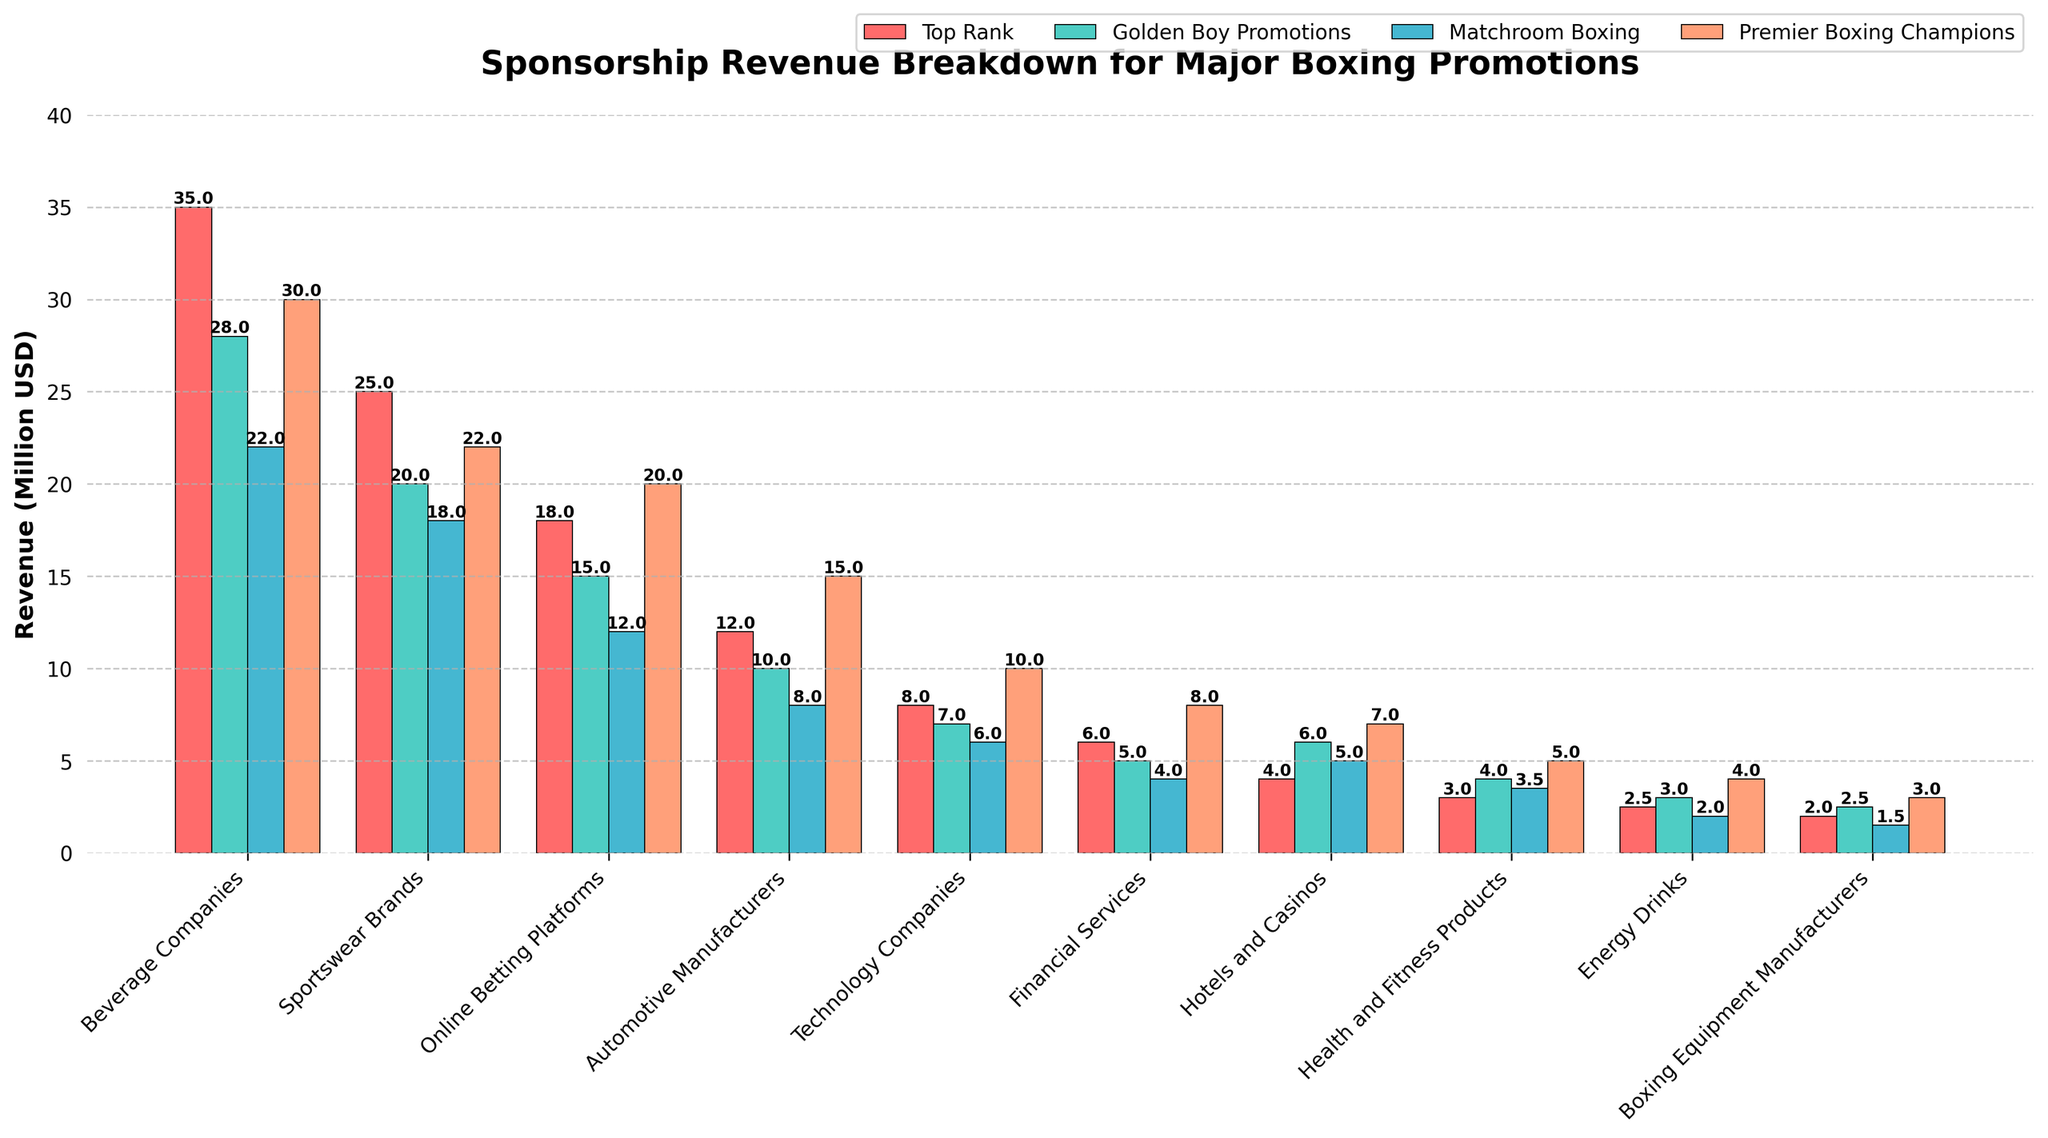What's the total sponsorship revenue for Top Rank across all industry sectors? To find this, sum up all the revenues for Top Rank: 35 + 25 + 18 + 12 + 8 + 6 + 4 + 3 + 2.5 + 2 = 115.5 million USD
Answer: 115.5 million USD Which industry sector brings the highest sponsorship revenue for Golden Boy Promotions? By examining the bars corresponding to Golden Boy Promotions, the Beverage Companies sector has the highest sponsorship revenue at 28 million USD
Answer: Beverage Companies Among all the promotions, which has the least revenue from the Automotive Manufacturers sector? Top Rank: 12 million, Golden Boy Promotions: 10 million, Matchroom Boxing: 8 million, Premier Boxing Champions: 15 million. Matchroom Boxing has the least at 8 million USD
Answer: Matchroom Boxing How much more revenue does Top Rank get from Beverage Companies compared to Technology Companies? Top Rank's revenue from Beverage Companies is 35 million, and from Technology Companies is 8 million. The difference is 35 - 8 = 27 million USD
Answer: 27 million USD Which promotion has the highest average revenue across all industry sectors? Calculate the average for each promotion: Top Rank: (35+25+18+12+8+6+4+3+2.5+2)/10 = 11.55 million USD, Golden Boy Promotions: (28+20+15+10+7+5+6+4+3+2.5)/10 = 10.15 million USD, Matchroom Boxing: (22+18+12+8+6+4+5+3.5+2+1.5)/10 = 8.95 million USD, Premier Boxing Champions: (30+22+20+15+10+8+7+5+4+3)/10 = 12.4 million USD. Premier Boxing Champions has the highest average at 12.4 million USD
Answer: Premier Boxing Champions Which promotion has the smallest revenue difference between the top two sectors? Calculate the difference for each promotion: Top Rank: 35-25=10, Golden Boy Promotions: 28-20=8, Matchroom Boxing: 22-18=4, Premier Boxing Champions: 30-22=8. Matchroom Boxing has the smallest difference at 4 million USD
Answer: Matchroom Boxing How much revenue does Premier Boxing Champions get from the three least contributing sectors? Identify the least contributing sectors: Technology Companies (10), Financial Services (8), Boxing Equipment Manufacturers (3). Summing these revenues: 10 + 8 + 3 = 21 million USD
Answer: 21 million USD Compare the revenue from Energy Drinks between Premier Boxing Champions and Matchroom Boxing. Which one earns more and by how much? Premier Boxing Champions has 4 million USD, while Matchroom Boxing has 2 million USD. The difference is 4 - 2 = 2 million USD
Answer: Premier Boxing Champions, 2 million USD What is the combined contribution of Online Betting Platforms to all promotions? Sum up the contributions from each promotion: 18 + 15 + 12 + 20 = 65 million USD
Answer: 65 million USD In which sector does Matchroom Boxing have the highest revenue, and what is the amount? By examining Matchroom Boxing's bars, the Beverage Companies sector has the highest revenue at 22 million USD
Answer: Beverage Companies, 22 million USD 